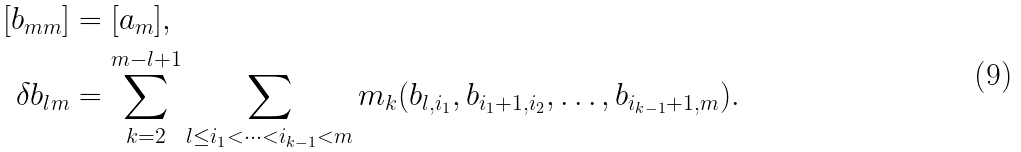<formula> <loc_0><loc_0><loc_500><loc_500>[ b _ { m m } ] & = [ a _ { m } ] , \\ \delta b _ { l m } & = \sum _ { k = 2 } ^ { m - l + 1 } \sum _ { l \leq i _ { 1 } < \cdots < i _ { k - 1 } < m } m _ { k } ( b _ { l , i _ { 1 } } , b _ { i _ { 1 } + 1 , i _ { 2 } } , \dots , b _ { i _ { k - 1 } + 1 , m } ) .</formula> 